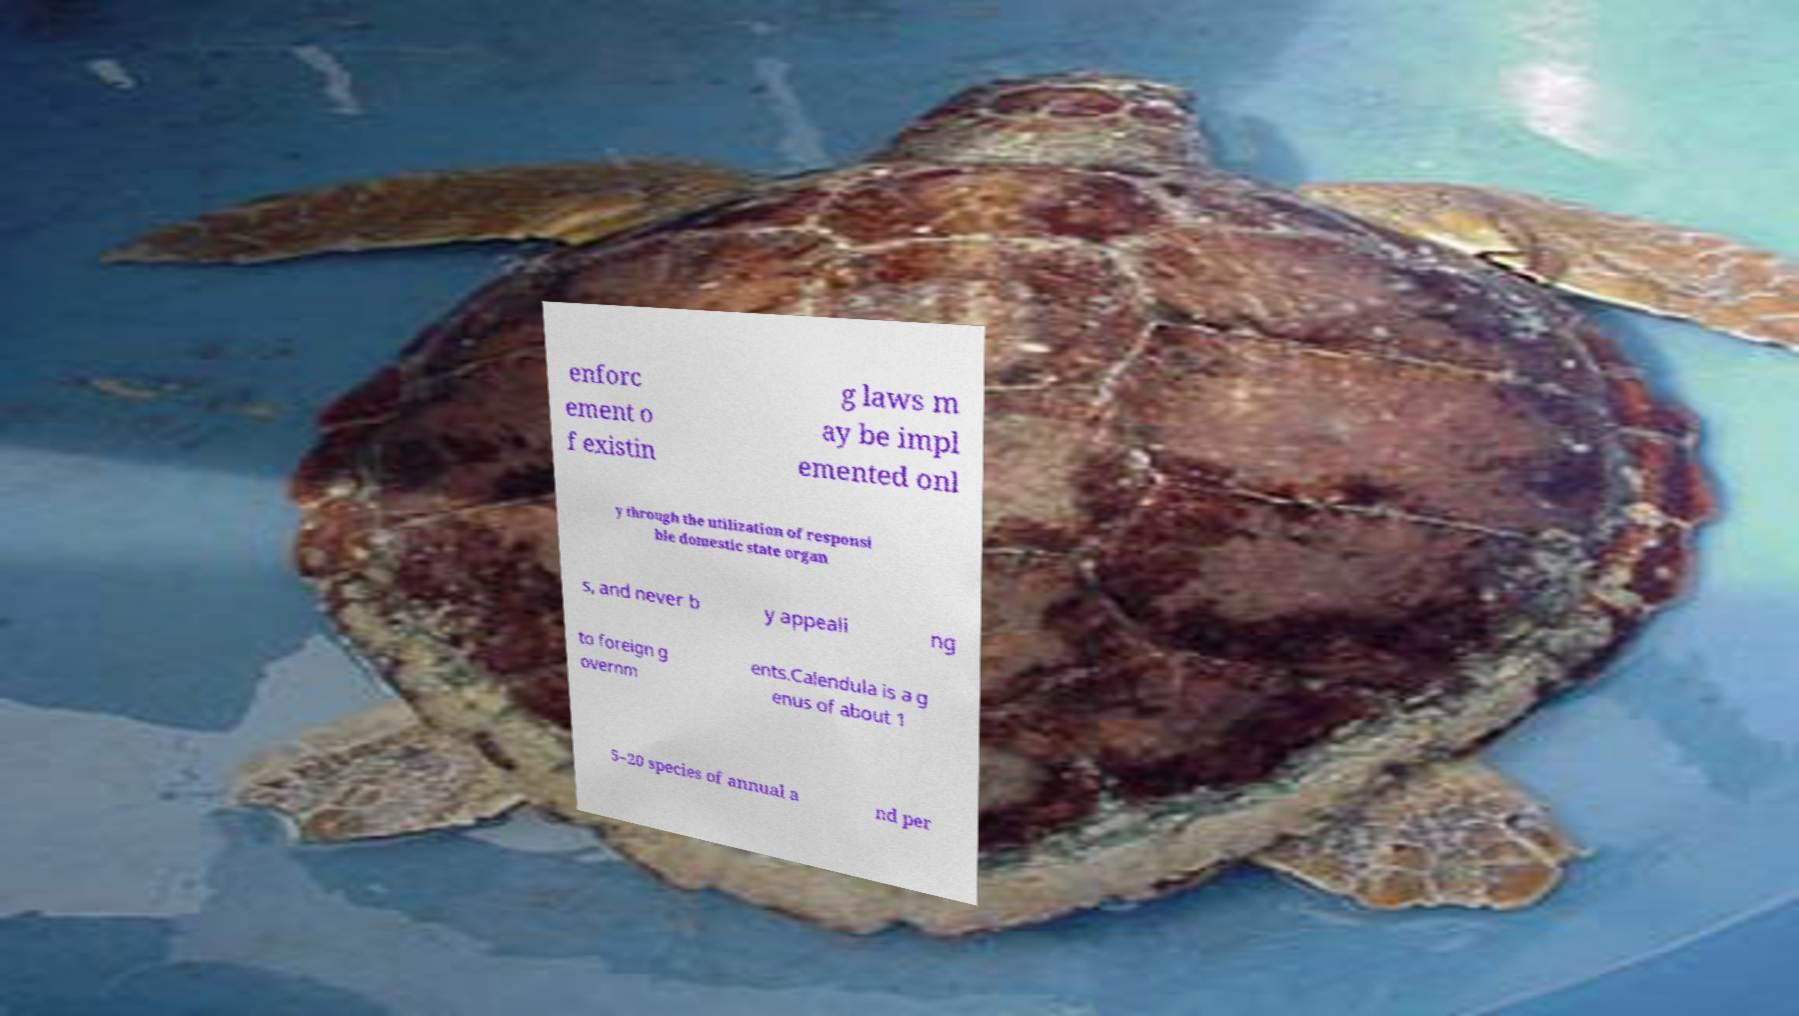For documentation purposes, I need the text within this image transcribed. Could you provide that? enforc ement o f existin g laws m ay be impl emented onl y through the utilization of responsi ble domestic state organ s, and never b y appeali ng to foreign g overnm ents.Calendula is a g enus of about 1 5–20 species of annual a nd per 